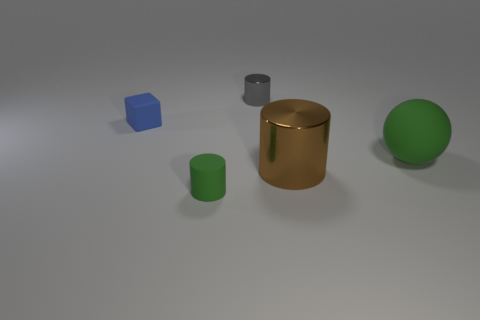There is a big matte object; is its shape the same as the green object that is left of the large metal cylinder? No, the big matte object, which appears to be a cuboid, does not share the same shape as the green object. The green object to the left of the large metal cylinder seems to be spherical, thus they have distinct geometric shapes. 